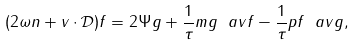<formula> <loc_0><loc_0><loc_500><loc_500>( 2 \omega n + { v } \cdot \mathcal { D } ) f = 2 \Psi g + \frac { 1 } { \tau } m g \ a v f - \frac { 1 } { \tau } p f \ a v g ,</formula> 